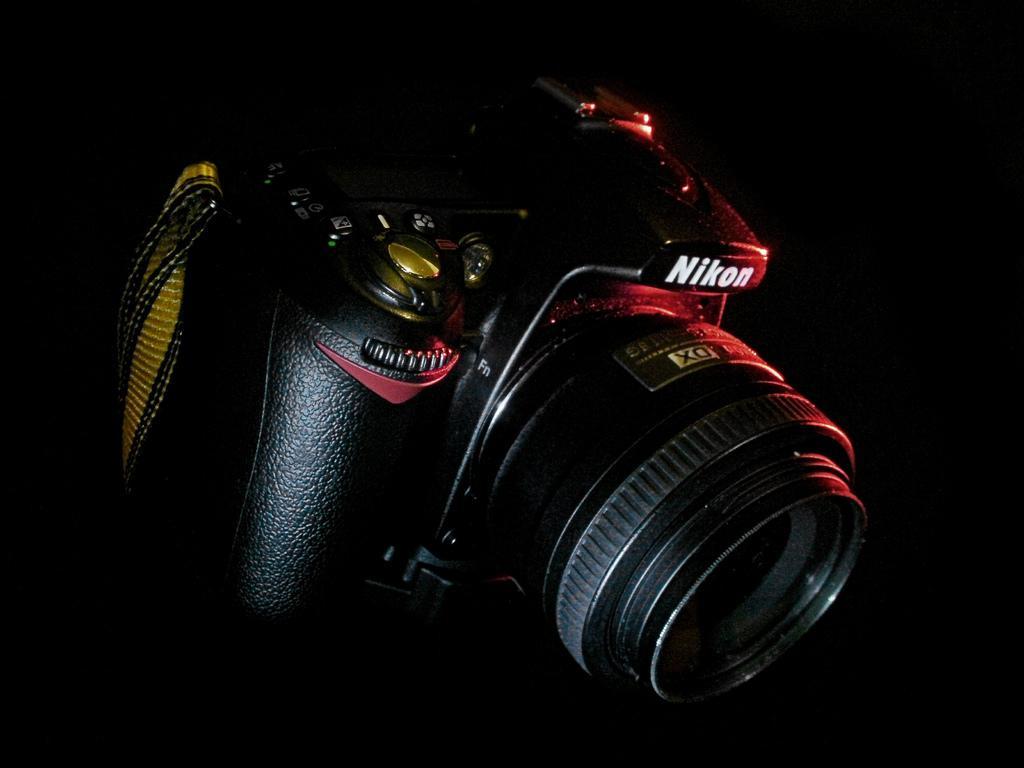Please provide a concise description of this image. Here we can see a camera and there is a dark background. 